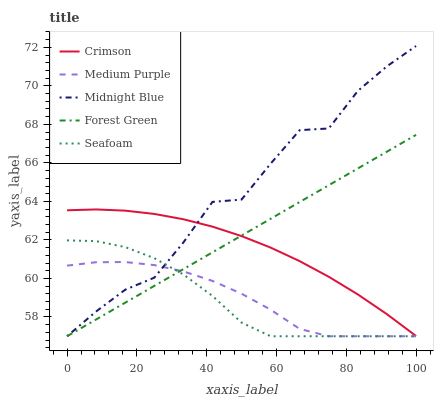Does Medium Purple have the minimum area under the curve?
Answer yes or no. No. Does Medium Purple have the maximum area under the curve?
Answer yes or no. No. Is Medium Purple the smoothest?
Answer yes or no. No. Is Medium Purple the roughest?
Answer yes or no. No. Does Forest Green have the highest value?
Answer yes or no. No. Is Seafoam less than Crimson?
Answer yes or no. Yes. Is Crimson greater than Medium Purple?
Answer yes or no. Yes. Does Seafoam intersect Crimson?
Answer yes or no. No. 